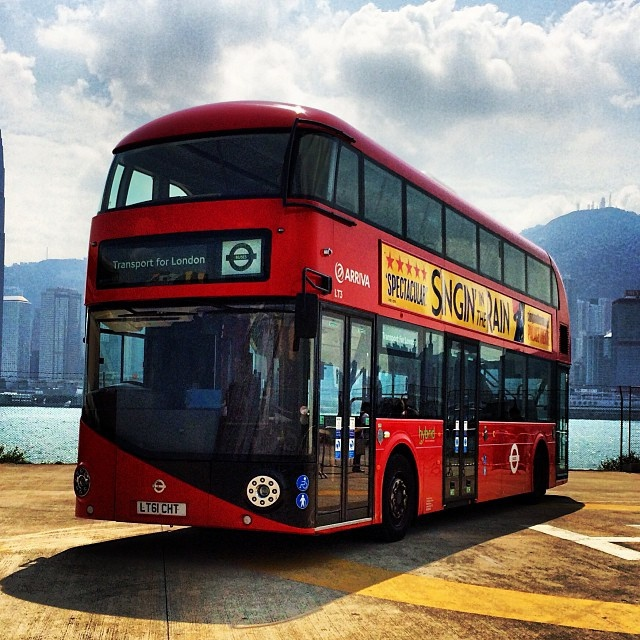Describe the objects in this image and their specific colors. I can see bus in lavender, black, maroon, brown, and gray tones in this image. 